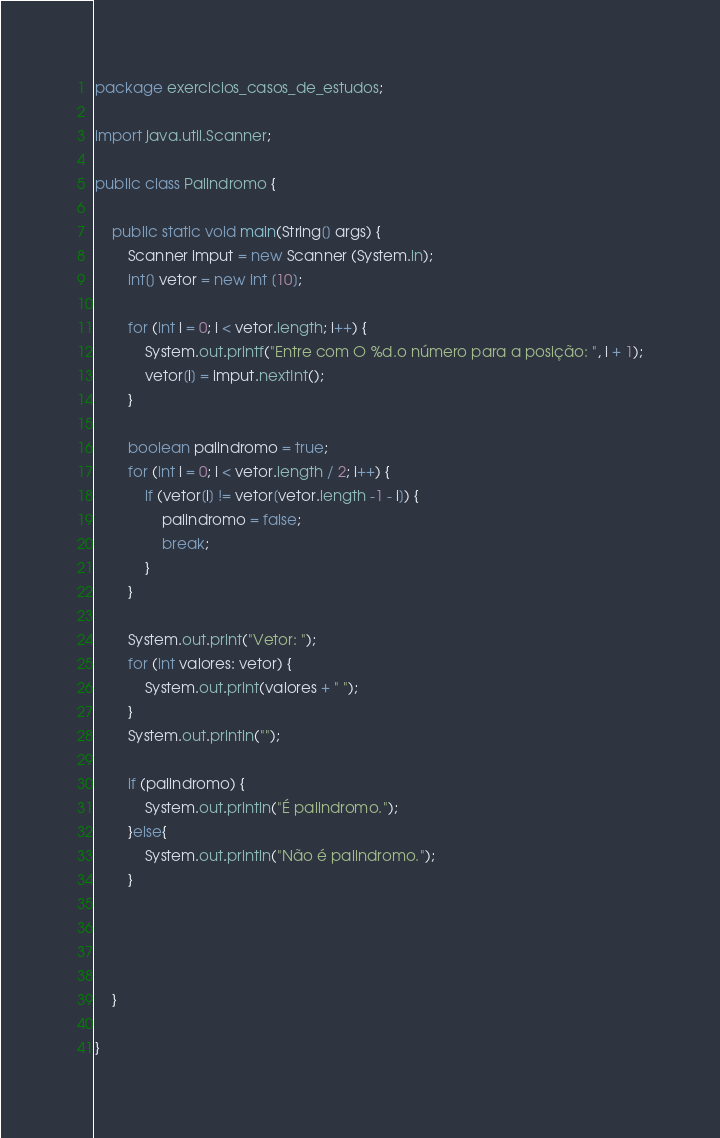<code> <loc_0><loc_0><loc_500><loc_500><_Java_>package exercicios_casos_de_estudos;

import java.util.Scanner;

public class Palindromo {
    
    public static void main(String[] args) {
        Scanner imput = new Scanner (System.in);
        int[] vetor = new int [10];
       
        for (int i = 0; i < vetor.length; i++) {
            System.out.printf("Entre com O %d.o número para a posição: ", i + 1);
            vetor[i] = imput.nextInt();
        }
        
        boolean palindromo = true;
        for (int i = 0; i < vetor.length / 2; i++) {
            if (vetor[i] != vetor[vetor.length -1 - i]) {
                palindromo = false;
                break;
            }
        }
        
        System.out.print("Vetor: ");
        for (int valores: vetor) {
            System.out.print(valores + " ");
        }
        System.out.println("");
        
        if (palindromo) {
            System.out.println("É palindromo.");
        }else{
            System.out.println("Não é palindromo.");
        }
       
        
        
        
    }
    
}
</code> 